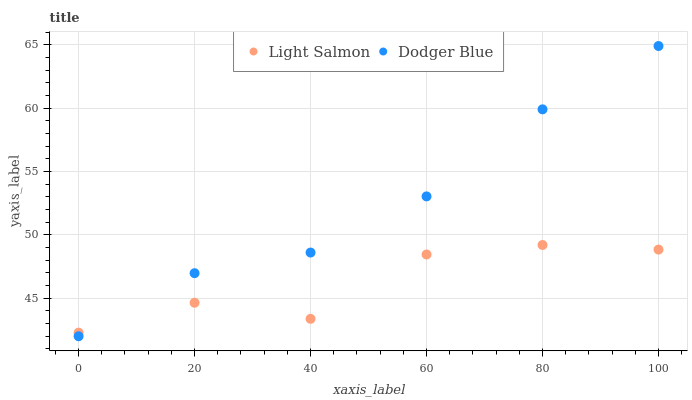Does Light Salmon have the minimum area under the curve?
Answer yes or no. Yes. Does Dodger Blue have the maximum area under the curve?
Answer yes or no. Yes. Does Dodger Blue have the minimum area under the curve?
Answer yes or no. No. Is Dodger Blue the smoothest?
Answer yes or no. Yes. Is Light Salmon the roughest?
Answer yes or no. Yes. Is Dodger Blue the roughest?
Answer yes or no. No. Does Dodger Blue have the lowest value?
Answer yes or no. Yes. Does Dodger Blue have the highest value?
Answer yes or no. Yes. Does Light Salmon intersect Dodger Blue?
Answer yes or no. Yes. Is Light Salmon less than Dodger Blue?
Answer yes or no. No. Is Light Salmon greater than Dodger Blue?
Answer yes or no. No. 